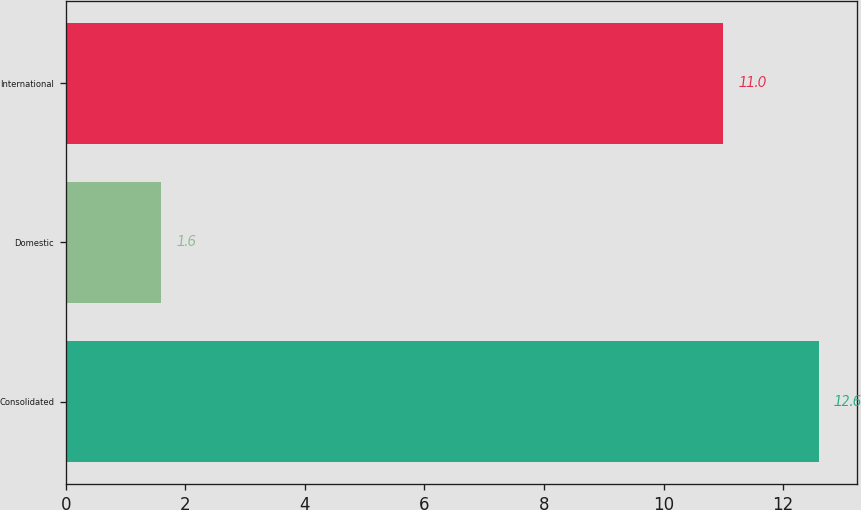<chart> <loc_0><loc_0><loc_500><loc_500><bar_chart><fcel>Consolidated<fcel>Domestic<fcel>International<nl><fcel>12.6<fcel>1.6<fcel>11<nl></chart> 